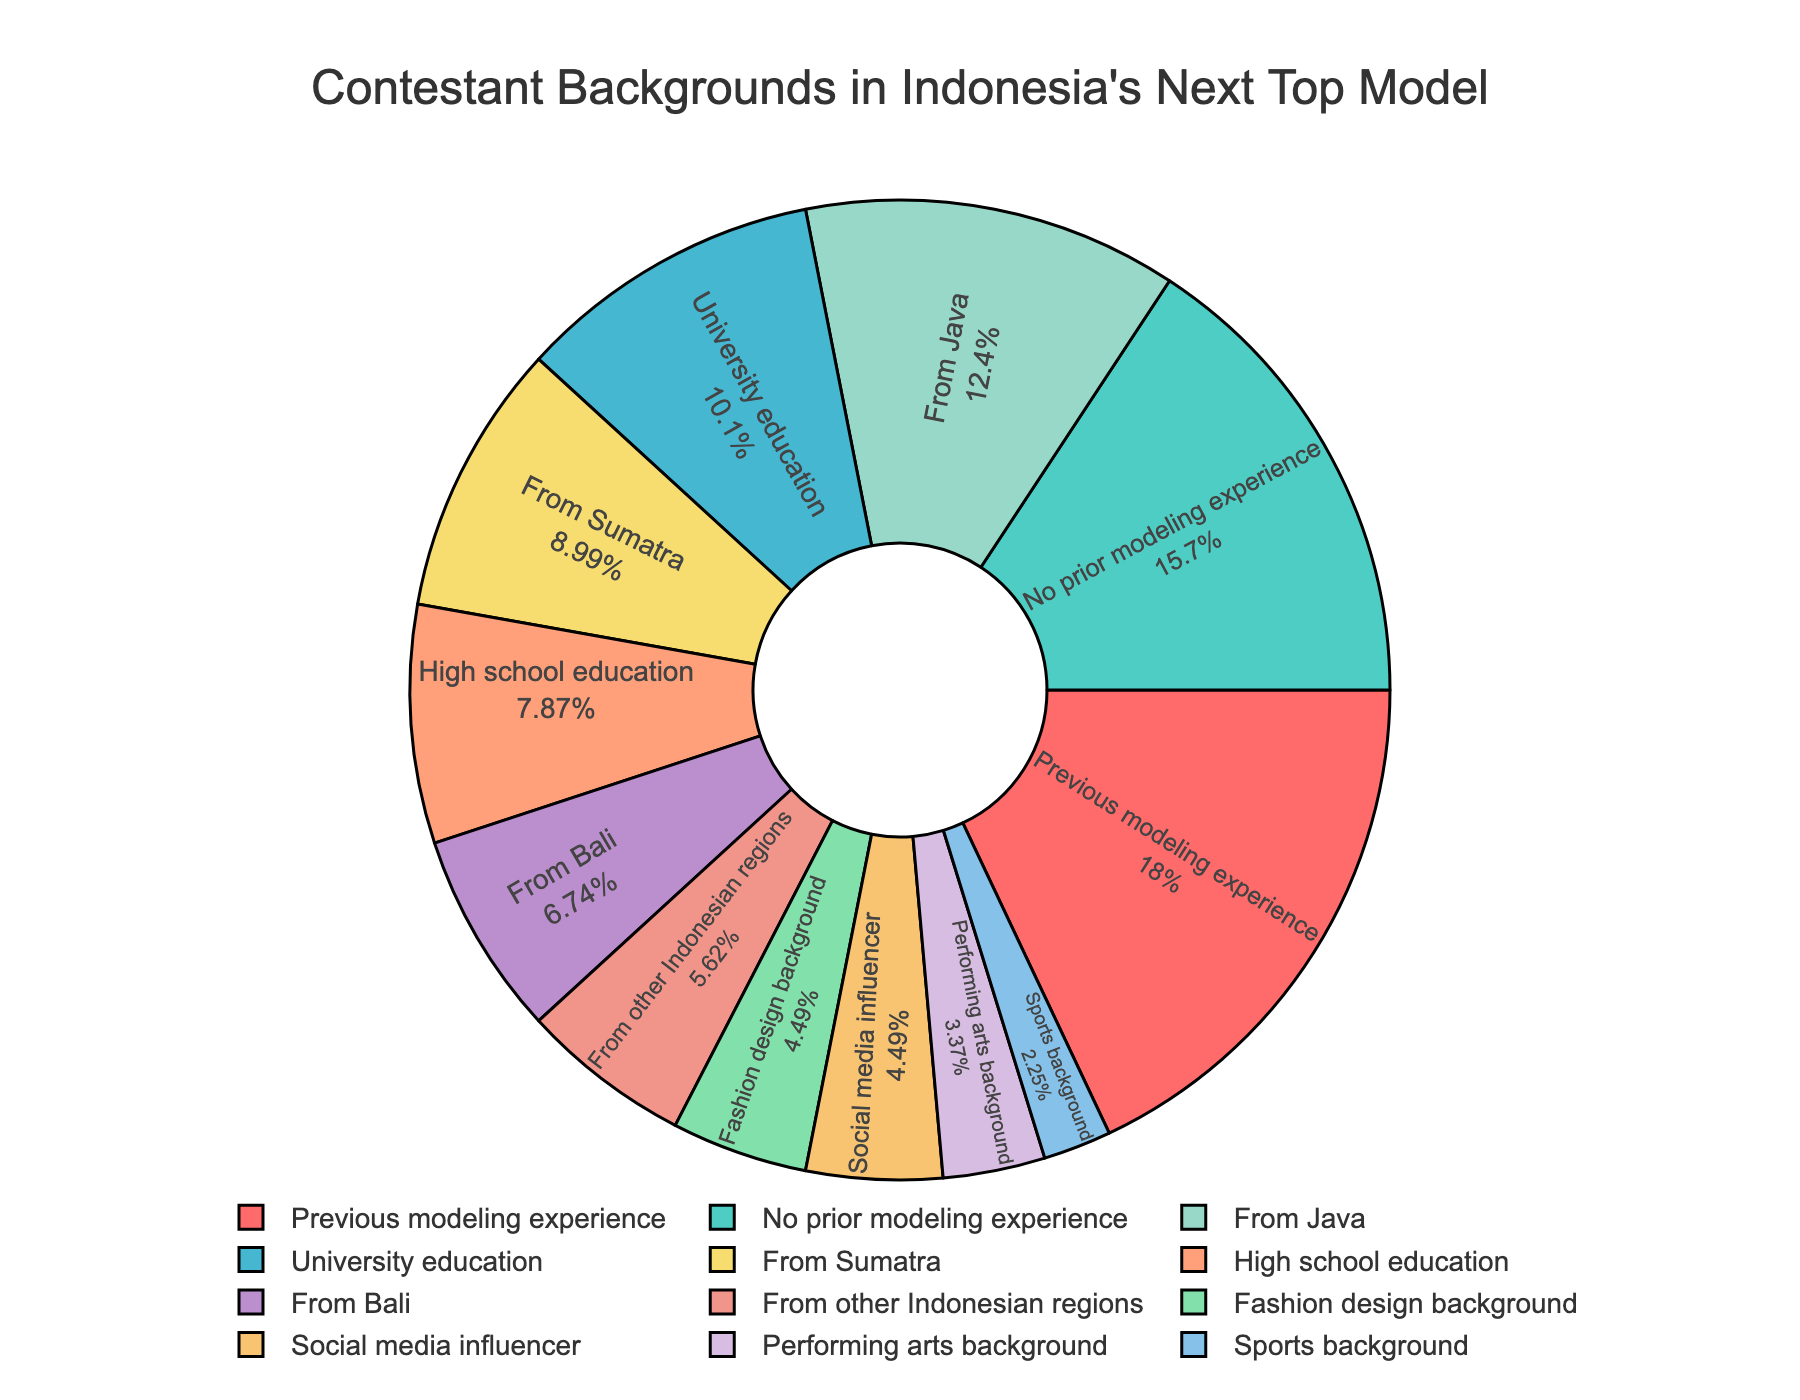What's the percentage of contestants with university and high school education combined? Sum the percentages of contestants with university education (18%) and high school education (14%). The combined percentage is 18 + 14 = 32%
Answer: 32% Which background category has the highest percentage of contestants? Check each slice of the pie chart to see which has the largest value. "Previous modeling experience" is the largest slice with 32%.
Answer: Previous modeling experience What is the difference in percentage between contestants from Java and those from Bali? Subtract the percentage of contestants from Bali (12%) from the percentage of contestants from Java (22%). The difference is 22 - 12 = 10%
Answer: 10% How many categories have a percentage of 10% or higher? Identify and count the slices that have a value of 10% or more. The categories are: Previous modeling experience (32%), No prior modeling experience (28%), University education (18%), High school education (14%), From Java (22%), From Sumatra (16%), and From Bali (12%). Thus, there are 7 categories.
Answer: 7 Do contestants with a fashion design background constitute a larger percentage than those from Sumatra? Compare the percentages of contestants with a fashion design background (8%) and those from Sumatra (16%). Since 16% is greater than 8%, contestants from Sumatra have a larger percentage.
Answer: No Which background categories each contribute to 8% of contestants? Identify the slices with 8% in the pie chart. The background categories are "Fashion design background" and "Social media influencer".
Answer: Fashion design background and Social media influencer What is the combined percentage of contestants with a performing arts or sports background? Sum the percentages for performing arts background (6%) and sports background (4%). The combined percentage is 6 + 4 = 10%
Answer: 10% Which category has a smaller percentage: social media influencer or no prior modeling experience? Compare the percentages for social media influencer (8%) and no prior modeling experience (28%). Since 8% is less than 28%, social media influencer has a smaller percentage.
Answer: Social media influencer What percentage of contestants do not have modeling experience prior to the show? Sum the percentages of contestants with no prior modeling experience (28%) and those from other backgrounds not specifically related to modeling. This is already identified in the data as 28%.
Answer: 28% From which Indonesian region do the least number of contestants come from? Identify the region with the smallest percentage. "From other Indonesian regions" has the smallest percentage at 10%.
Answer: Other Indonesian regions 